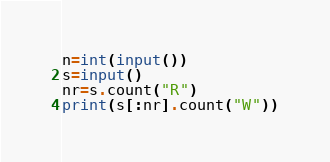<code> <loc_0><loc_0><loc_500><loc_500><_Python_>n=int(input())
s=input()
nr=s.count("R")
print(s[:nr].count("W"))</code> 